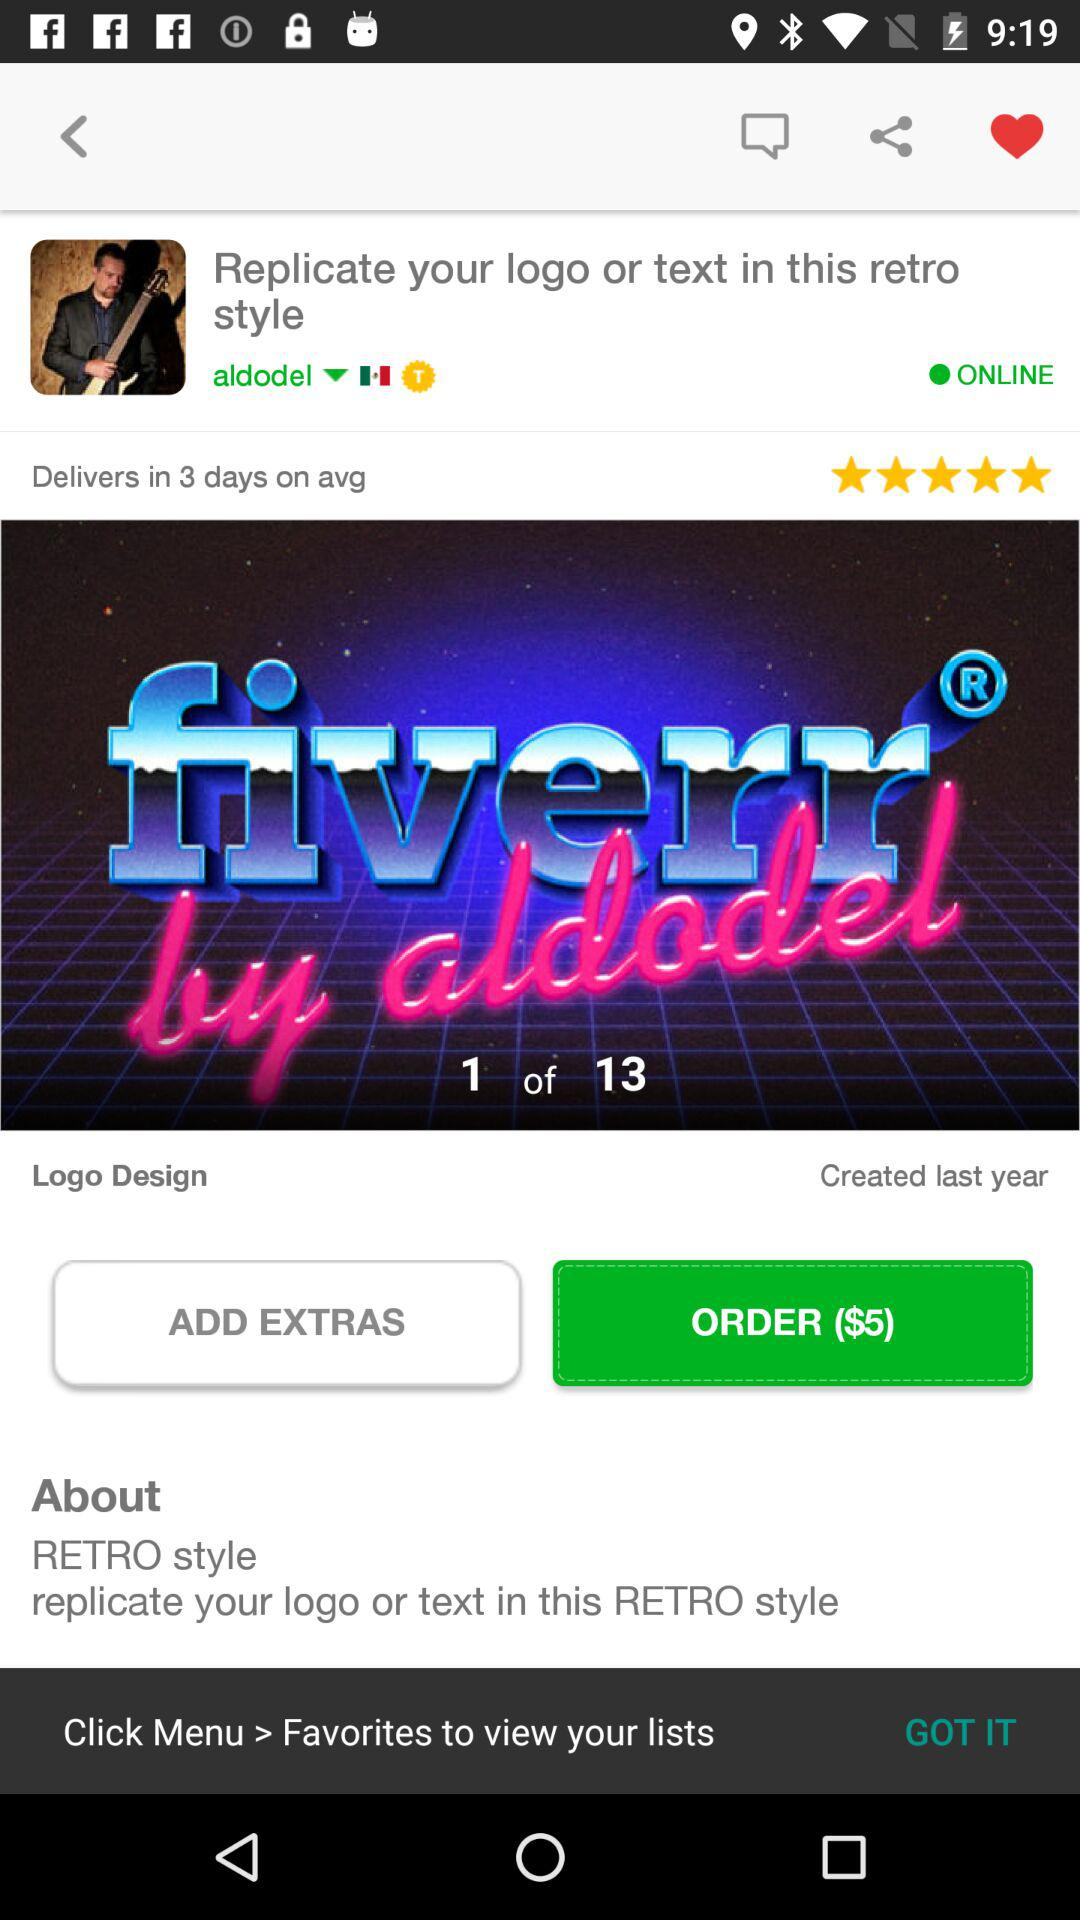In how many days will it be delivered? It will be delivered in 3 days on average. 